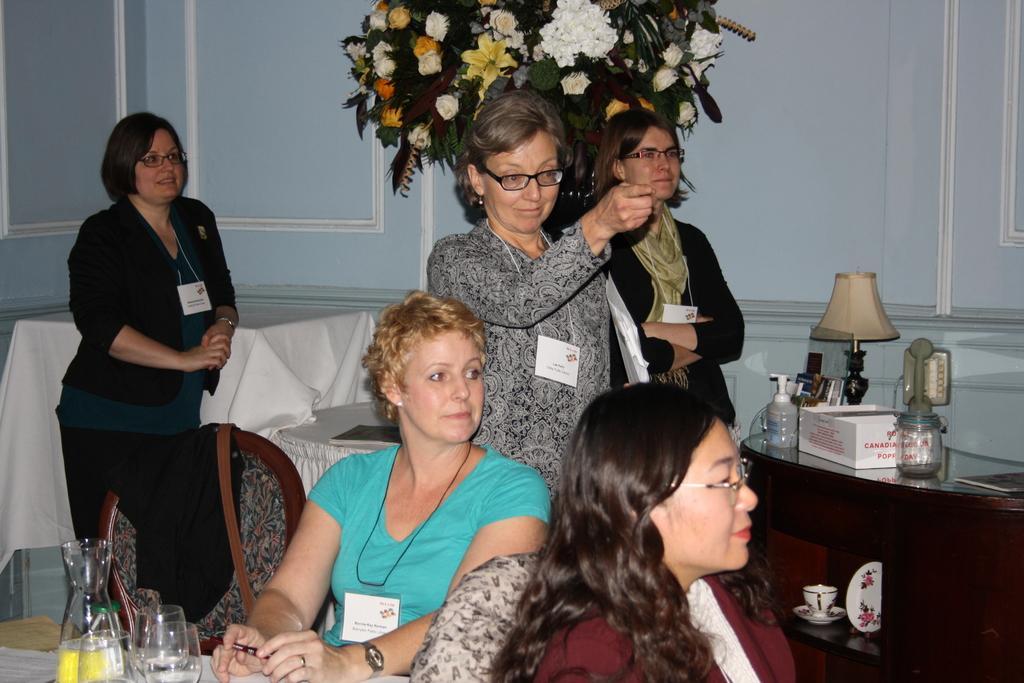Can you describe this image briefly? In this image I can see some people. I can see some objects on the table. In the background, I can see the wall and a tree. 